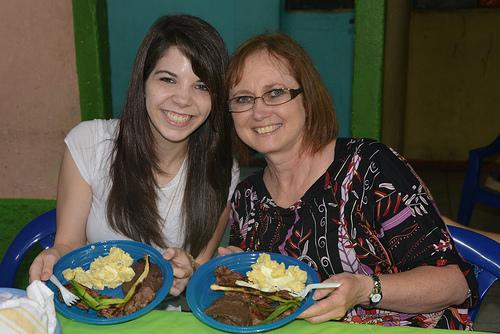Question: why the women are smiling?
Choices:
A. They saw something funny happen.
B. They are happy.
C. They just became grandmothers.
D. They are playing a fun game.
Answer with the letter. Answer: B Question: what is the color of the plates?
Choices:
A. Green.
B. Blue.
C. Yellow.
D. Pink.
Answer with the letter. Answer: B Question: what is on the plate?
Choices:
A. A blood sample.
B. Another plate.
C. Food.
D. A seed.
Answer with the letter. Answer: C Question: what is the women's hair color?
Choices:
A. Brown.
B. Black.
C. Blonde.
D. Red.
Answer with the letter. Answer: A Question: how many women holding the plates?
Choices:
A. Two.
B. Three.
C. Four.
D. Five.
Answer with the letter. Answer: A Question: where is the plates?
Choices:
A. In the cupboard.
B. On the table.
C. On women's hands.
D. In a box.
Answer with the letter. Answer: C Question: who is holding the plates?
Choices:
A. Children.
B. Men.
C. Grandparents.
D. Women.
Answer with the letter. Answer: D 